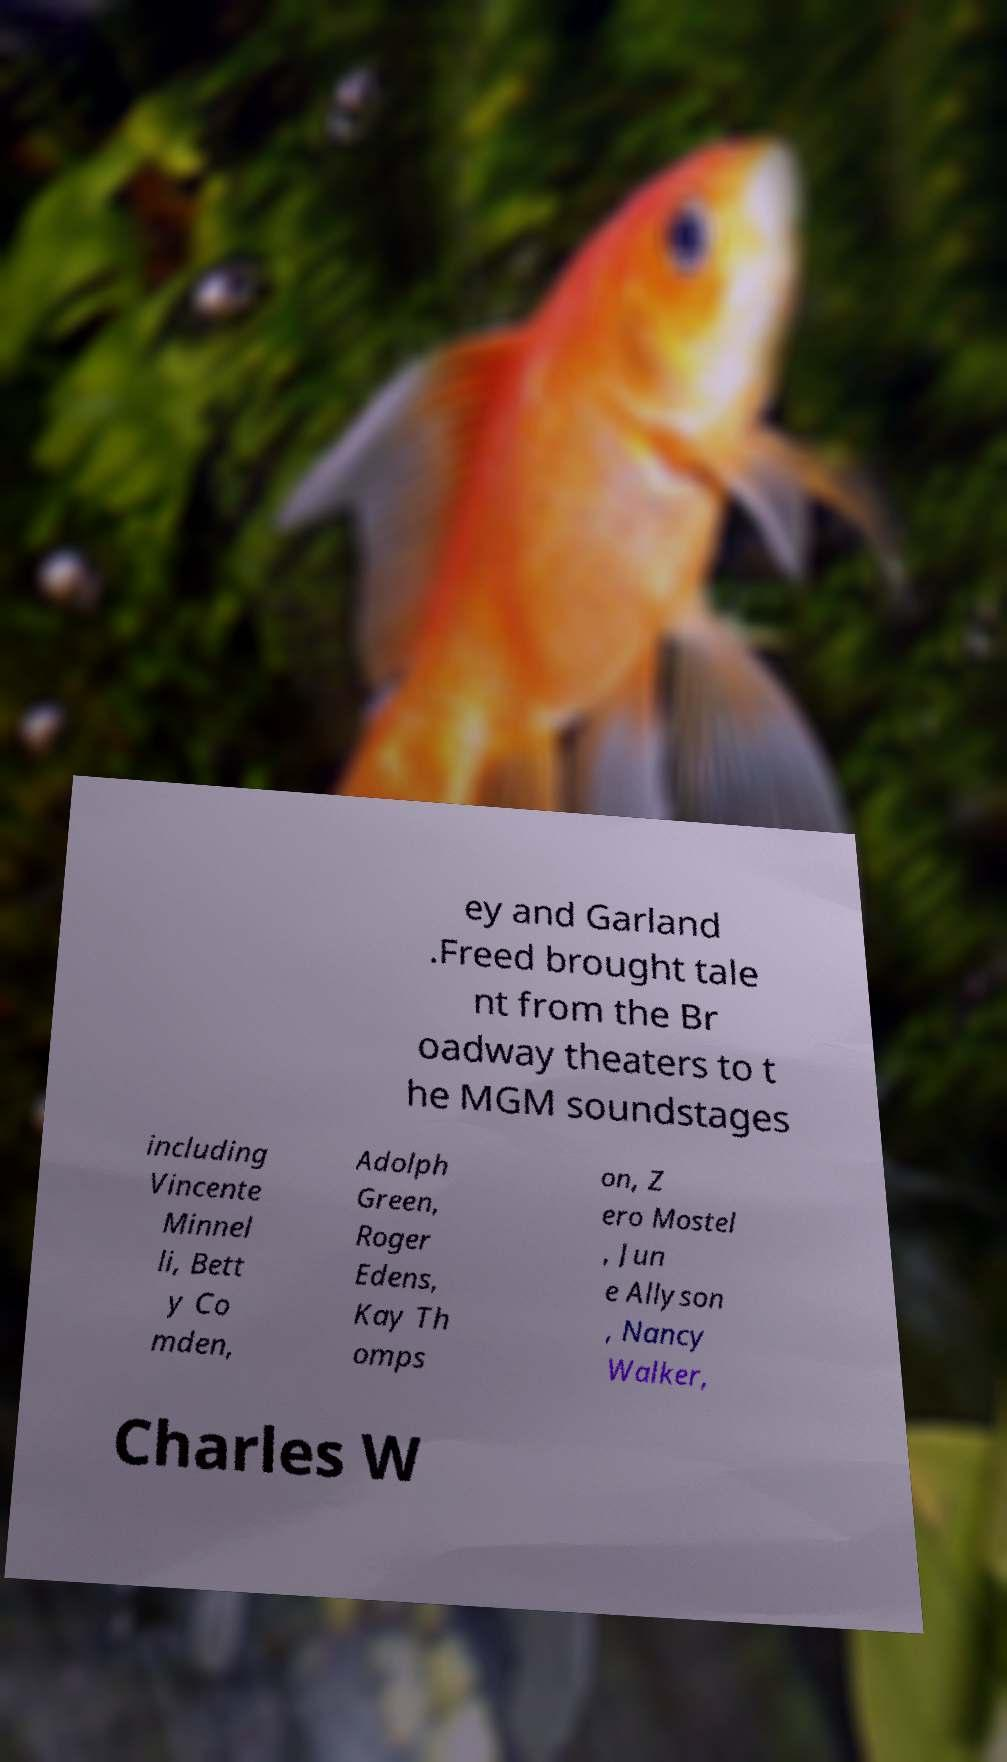Please identify and transcribe the text found in this image. ey and Garland .Freed brought tale nt from the Br oadway theaters to t he MGM soundstages including Vincente Minnel li, Bett y Co mden, Adolph Green, Roger Edens, Kay Th omps on, Z ero Mostel , Jun e Allyson , Nancy Walker, Charles W 